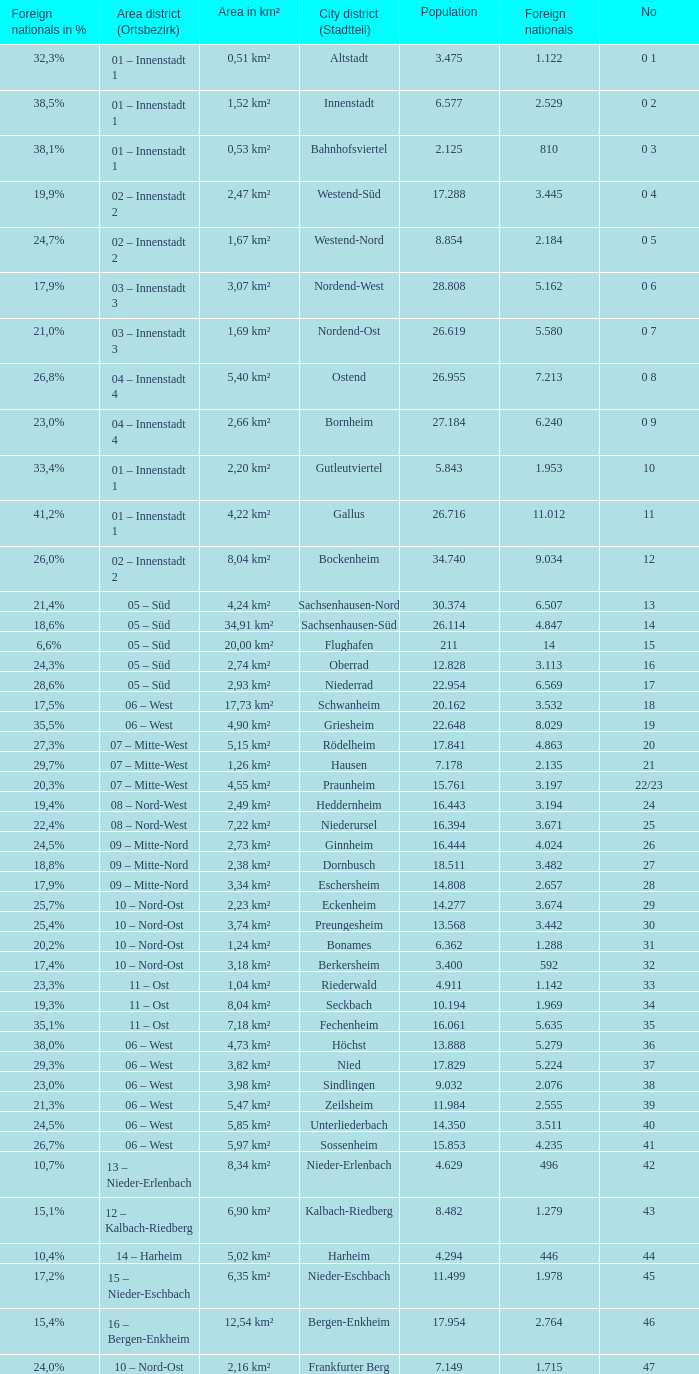Help me parse the entirety of this table. {'header': ['Foreign nationals in %', 'Area district (Ortsbezirk)', 'Area in km²', 'City district (Stadtteil)', 'Population', 'Foreign nationals', 'No'], 'rows': [['32,3%', '01 – Innenstadt 1', '0,51 km²', 'Altstadt', '3.475', '1.122', '0 1'], ['38,5%', '01 – Innenstadt 1', '1,52 km²', 'Innenstadt', '6.577', '2.529', '0 2'], ['38,1%', '01 – Innenstadt 1', '0,53 km²', 'Bahnhofsviertel', '2.125', '810', '0 3'], ['19,9%', '02 – Innenstadt 2', '2,47 km²', 'Westend-Süd', '17.288', '3.445', '0 4'], ['24,7%', '02 – Innenstadt 2', '1,67 km²', 'Westend-Nord', '8.854', '2.184', '0 5'], ['17,9%', '03 – Innenstadt 3', '3,07 km²', 'Nordend-West', '28.808', '5.162', '0 6'], ['21,0%', '03 – Innenstadt 3', '1,69 km²', 'Nordend-Ost', '26.619', '5.580', '0 7'], ['26,8%', '04 – Innenstadt 4', '5,40 km²', 'Ostend', '26.955', '7.213', '0 8'], ['23,0%', '04 – Innenstadt 4', '2,66 km²', 'Bornheim', '27.184', '6.240', '0 9'], ['33,4%', '01 – Innenstadt 1', '2,20 km²', 'Gutleutviertel', '5.843', '1.953', '10'], ['41,2%', '01 – Innenstadt 1', '4,22 km²', 'Gallus', '26.716', '11.012', '11'], ['26,0%', '02 – Innenstadt 2', '8,04 km²', 'Bockenheim', '34.740', '9.034', '12'], ['21,4%', '05 – Süd', '4,24 km²', 'Sachsenhausen-Nord', '30.374', '6.507', '13'], ['18,6%', '05 – Süd', '34,91 km²', 'Sachsenhausen-Süd', '26.114', '4.847', '14'], ['6,6%', '05 – Süd', '20,00 km²', 'Flughafen', '211', '14', '15'], ['24,3%', '05 – Süd', '2,74 km²', 'Oberrad', '12.828', '3.113', '16'], ['28,6%', '05 – Süd', '2,93 km²', 'Niederrad', '22.954', '6.569', '17'], ['17,5%', '06 – West', '17,73 km²', 'Schwanheim', '20.162', '3.532', '18'], ['35,5%', '06 – West', '4,90 km²', 'Griesheim', '22.648', '8.029', '19'], ['27,3%', '07 – Mitte-West', '5,15 km²', 'Rödelheim', '17.841', '4.863', '20'], ['29,7%', '07 – Mitte-West', '1,26 km²', 'Hausen', '7.178', '2.135', '21'], ['20,3%', '07 – Mitte-West', '4,55 km²', 'Praunheim', '15.761', '3.197', '22/23'], ['19,4%', '08 – Nord-West', '2,49 km²', 'Heddernheim', '16.443', '3.194', '24'], ['22,4%', '08 – Nord-West', '7,22 km²', 'Niederursel', '16.394', '3.671', '25'], ['24,5%', '09 – Mitte-Nord', '2,73 km²', 'Ginnheim', '16.444', '4.024', '26'], ['18,8%', '09 – Mitte-Nord', '2,38 km²', 'Dornbusch', '18.511', '3.482', '27'], ['17,9%', '09 – Mitte-Nord', '3,34 km²', 'Eschersheim', '14.808', '2.657', '28'], ['25,7%', '10 – Nord-Ost', '2,23 km²', 'Eckenheim', '14.277', '3.674', '29'], ['25,4%', '10 – Nord-Ost', '3,74 km²', 'Preungesheim', '13.568', '3.442', '30'], ['20,2%', '10 – Nord-Ost', '1,24 km²', 'Bonames', '6.362', '1.288', '31'], ['17,4%', '10 – Nord-Ost', '3,18 km²', 'Berkersheim', '3.400', '592', '32'], ['23,3%', '11 – Ost', '1,04 km²', 'Riederwald', '4.911', '1.142', '33'], ['19,3%', '11 – Ost', '8,04 km²', 'Seckbach', '10.194', '1.969', '34'], ['35,1%', '11 – Ost', '7,18 km²', 'Fechenheim', '16.061', '5.635', '35'], ['38,0%', '06 – West', '4,73 km²', 'Höchst', '13.888', '5.279', '36'], ['29,3%', '06 – West', '3,82 km²', 'Nied', '17.829', '5.224', '37'], ['23,0%', '06 – West', '3,98 km²', 'Sindlingen', '9.032', '2.076', '38'], ['21,3%', '06 – West', '5,47 km²', 'Zeilsheim', '11.984', '2.555', '39'], ['24,5%', '06 – West', '5,85 km²', 'Unterliederbach', '14.350', '3.511', '40'], ['26,7%', '06 – West', '5,97 km²', 'Sossenheim', '15.853', '4.235', '41'], ['10,7%', '13 – Nieder-Erlenbach', '8,34 km²', 'Nieder-Erlenbach', '4.629', '496', '42'], ['15,1%', '12 – Kalbach-Riedberg', '6,90 km²', 'Kalbach-Riedberg', '8.482', '1.279', '43'], ['10,4%', '14 – Harheim', '5,02 km²', 'Harheim', '4.294', '446', '44'], ['17,2%', '15 – Nieder-Eschbach', '6,35 km²', 'Nieder-Eschbach', '11.499', '1.978', '45'], ['15,4%', '16 – Bergen-Enkheim', '12,54 km²', 'Bergen-Enkheim', '17.954', '2.764', '46'], ['24,0%', '10 – Nord-Ost', '2,16 km²', 'Frankfurter Berg', '7.149', '1.715', '47']]} What is the number of the city district of stadtteil where foreigners are 5.162? 1.0. 